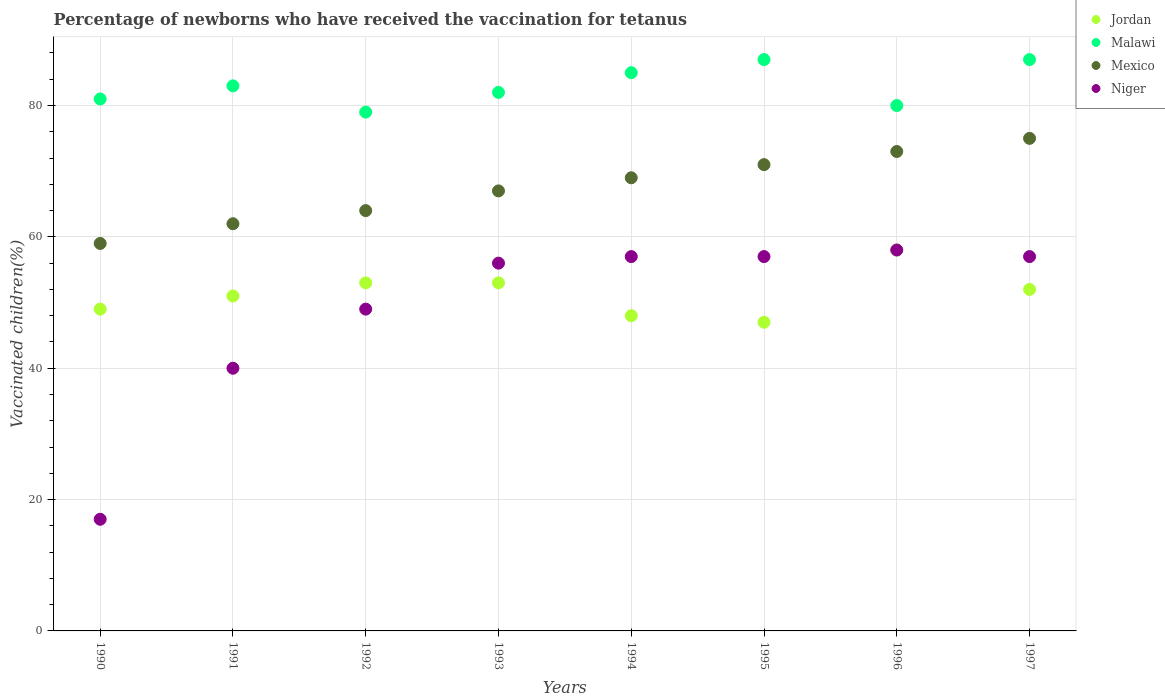Is the number of dotlines equal to the number of legend labels?
Make the answer very short. Yes. What is the percentage of vaccinated children in Jordan in 1995?
Your answer should be very brief. 47. In which year was the percentage of vaccinated children in Malawi maximum?
Offer a very short reply. 1995. What is the total percentage of vaccinated children in Jordan in the graph?
Your answer should be very brief. 411. What is the difference between the percentage of vaccinated children in Mexico in 1990 and that in 1997?
Ensure brevity in your answer.  -16. What is the difference between the percentage of vaccinated children in Mexico in 1993 and the percentage of vaccinated children in Malawi in 1991?
Give a very brief answer. -16. What is the average percentage of vaccinated children in Jordan per year?
Provide a short and direct response. 51.38. What is the ratio of the percentage of vaccinated children in Jordan in 1990 to that in 1992?
Your answer should be compact. 0.92. Is the difference between the percentage of vaccinated children in Jordan in 1990 and 1991 greater than the difference between the percentage of vaccinated children in Mexico in 1990 and 1991?
Keep it short and to the point. Yes. What is the difference between the highest and the second highest percentage of vaccinated children in Malawi?
Keep it short and to the point. 0. What is the difference between the highest and the lowest percentage of vaccinated children in Mexico?
Make the answer very short. 16. Is it the case that in every year, the sum of the percentage of vaccinated children in Niger and percentage of vaccinated children in Mexico  is greater than the sum of percentage of vaccinated children in Jordan and percentage of vaccinated children in Malawi?
Your answer should be compact. No. Does the percentage of vaccinated children in Mexico monotonically increase over the years?
Your response must be concise. Yes. Is the percentage of vaccinated children in Jordan strictly less than the percentage of vaccinated children in Mexico over the years?
Your answer should be compact. Yes. How many dotlines are there?
Offer a very short reply. 4. What is the difference between two consecutive major ticks on the Y-axis?
Your response must be concise. 20. Does the graph contain any zero values?
Give a very brief answer. No. Does the graph contain grids?
Your answer should be compact. Yes. How many legend labels are there?
Ensure brevity in your answer.  4. How are the legend labels stacked?
Ensure brevity in your answer.  Vertical. What is the title of the graph?
Keep it short and to the point. Percentage of newborns who have received the vaccination for tetanus. What is the label or title of the X-axis?
Provide a short and direct response. Years. What is the label or title of the Y-axis?
Make the answer very short. Vaccinated children(%). What is the Vaccinated children(%) in Jordan in 1990?
Offer a very short reply. 49. What is the Vaccinated children(%) of Mexico in 1990?
Make the answer very short. 59. What is the Vaccinated children(%) of Niger in 1990?
Your answer should be very brief. 17. What is the Vaccinated children(%) of Malawi in 1991?
Make the answer very short. 83. What is the Vaccinated children(%) in Niger in 1991?
Provide a succinct answer. 40. What is the Vaccinated children(%) of Malawi in 1992?
Keep it short and to the point. 79. What is the Vaccinated children(%) in Jordan in 1993?
Ensure brevity in your answer.  53. What is the Vaccinated children(%) of Malawi in 1993?
Offer a terse response. 82. What is the Vaccinated children(%) of Mexico in 1993?
Keep it short and to the point. 67. What is the Vaccinated children(%) in Niger in 1993?
Your response must be concise. 56. What is the Vaccinated children(%) in Jordan in 1994?
Offer a very short reply. 48. What is the Vaccinated children(%) in Malawi in 1994?
Provide a succinct answer. 85. What is the Vaccinated children(%) in Mexico in 1995?
Make the answer very short. 71. What is the Vaccinated children(%) in Malawi in 1996?
Your answer should be very brief. 80. What is the Vaccinated children(%) in Niger in 1996?
Provide a short and direct response. 58. What is the Vaccinated children(%) in Jordan in 1997?
Give a very brief answer. 52. What is the Vaccinated children(%) of Malawi in 1997?
Your answer should be compact. 87. What is the Vaccinated children(%) of Mexico in 1997?
Keep it short and to the point. 75. What is the Vaccinated children(%) of Niger in 1997?
Offer a very short reply. 57. Across all years, what is the maximum Vaccinated children(%) of Malawi?
Provide a succinct answer. 87. Across all years, what is the maximum Vaccinated children(%) of Mexico?
Make the answer very short. 75. Across all years, what is the minimum Vaccinated children(%) in Malawi?
Your answer should be very brief. 79. Across all years, what is the minimum Vaccinated children(%) in Niger?
Make the answer very short. 17. What is the total Vaccinated children(%) in Jordan in the graph?
Make the answer very short. 411. What is the total Vaccinated children(%) in Malawi in the graph?
Make the answer very short. 664. What is the total Vaccinated children(%) in Mexico in the graph?
Give a very brief answer. 540. What is the total Vaccinated children(%) in Niger in the graph?
Make the answer very short. 391. What is the difference between the Vaccinated children(%) in Jordan in 1990 and that in 1991?
Offer a terse response. -2. What is the difference between the Vaccinated children(%) of Mexico in 1990 and that in 1991?
Your answer should be very brief. -3. What is the difference between the Vaccinated children(%) of Niger in 1990 and that in 1991?
Offer a very short reply. -23. What is the difference between the Vaccinated children(%) in Niger in 1990 and that in 1992?
Your response must be concise. -32. What is the difference between the Vaccinated children(%) in Jordan in 1990 and that in 1993?
Make the answer very short. -4. What is the difference between the Vaccinated children(%) of Malawi in 1990 and that in 1993?
Your response must be concise. -1. What is the difference between the Vaccinated children(%) of Mexico in 1990 and that in 1993?
Offer a terse response. -8. What is the difference between the Vaccinated children(%) in Niger in 1990 and that in 1993?
Ensure brevity in your answer.  -39. What is the difference between the Vaccinated children(%) of Niger in 1990 and that in 1994?
Make the answer very short. -40. What is the difference between the Vaccinated children(%) in Jordan in 1990 and that in 1995?
Your answer should be very brief. 2. What is the difference between the Vaccinated children(%) in Malawi in 1990 and that in 1995?
Provide a short and direct response. -6. What is the difference between the Vaccinated children(%) of Malawi in 1990 and that in 1996?
Your response must be concise. 1. What is the difference between the Vaccinated children(%) of Niger in 1990 and that in 1996?
Offer a terse response. -41. What is the difference between the Vaccinated children(%) of Jordan in 1990 and that in 1997?
Your answer should be very brief. -3. What is the difference between the Vaccinated children(%) of Malawi in 1990 and that in 1997?
Provide a succinct answer. -6. What is the difference between the Vaccinated children(%) of Niger in 1990 and that in 1997?
Ensure brevity in your answer.  -40. What is the difference between the Vaccinated children(%) in Jordan in 1991 and that in 1992?
Your response must be concise. -2. What is the difference between the Vaccinated children(%) in Mexico in 1991 and that in 1992?
Your answer should be compact. -2. What is the difference between the Vaccinated children(%) in Mexico in 1991 and that in 1993?
Make the answer very short. -5. What is the difference between the Vaccinated children(%) of Niger in 1991 and that in 1993?
Offer a very short reply. -16. What is the difference between the Vaccinated children(%) of Malawi in 1991 and that in 1994?
Give a very brief answer. -2. What is the difference between the Vaccinated children(%) of Niger in 1991 and that in 1994?
Ensure brevity in your answer.  -17. What is the difference between the Vaccinated children(%) in Jordan in 1991 and that in 1995?
Provide a succinct answer. 4. What is the difference between the Vaccinated children(%) of Mexico in 1991 and that in 1995?
Make the answer very short. -9. What is the difference between the Vaccinated children(%) in Niger in 1991 and that in 1995?
Your response must be concise. -17. What is the difference between the Vaccinated children(%) of Jordan in 1991 and that in 1996?
Your answer should be compact. -7. What is the difference between the Vaccinated children(%) of Malawi in 1991 and that in 1996?
Provide a succinct answer. 3. What is the difference between the Vaccinated children(%) in Jordan in 1991 and that in 1997?
Your response must be concise. -1. What is the difference between the Vaccinated children(%) of Malawi in 1991 and that in 1997?
Make the answer very short. -4. What is the difference between the Vaccinated children(%) in Mexico in 1991 and that in 1997?
Provide a succinct answer. -13. What is the difference between the Vaccinated children(%) in Malawi in 1992 and that in 1993?
Your answer should be very brief. -3. What is the difference between the Vaccinated children(%) in Jordan in 1992 and that in 1994?
Offer a very short reply. 5. What is the difference between the Vaccinated children(%) in Niger in 1992 and that in 1994?
Your answer should be very brief. -8. What is the difference between the Vaccinated children(%) in Malawi in 1992 and that in 1995?
Make the answer very short. -8. What is the difference between the Vaccinated children(%) of Mexico in 1992 and that in 1995?
Offer a very short reply. -7. What is the difference between the Vaccinated children(%) of Jordan in 1992 and that in 1996?
Give a very brief answer. -5. What is the difference between the Vaccinated children(%) in Malawi in 1992 and that in 1996?
Provide a succinct answer. -1. What is the difference between the Vaccinated children(%) in Mexico in 1992 and that in 1996?
Provide a short and direct response. -9. What is the difference between the Vaccinated children(%) of Malawi in 1992 and that in 1997?
Keep it short and to the point. -8. What is the difference between the Vaccinated children(%) in Mexico in 1992 and that in 1997?
Give a very brief answer. -11. What is the difference between the Vaccinated children(%) of Jordan in 1993 and that in 1994?
Ensure brevity in your answer.  5. What is the difference between the Vaccinated children(%) of Mexico in 1993 and that in 1994?
Provide a short and direct response. -2. What is the difference between the Vaccinated children(%) of Niger in 1993 and that in 1994?
Give a very brief answer. -1. What is the difference between the Vaccinated children(%) in Jordan in 1993 and that in 1996?
Give a very brief answer. -5. What is the difference between the Vaccinated children(%) of Malawi in 1993 and that in 1996?
Ensure brevity in your answer.  2. What is the difference between the Vaccinated children(%) in Mexico in 1993 and that in 1996?
Your answer should be very brief. -6. What is the difference between the Vaccinated children(%) of Mexico in 1993 and that in 1997?
Make the answer very short. -8. What is the difference between the Vaccinated children(%) in Niger in 1993 and that in 1997?
Provide a succinct answer. -1. What is the difference between the Vaccinated children(%) of Malawi in 1994 and that in 1996?
Your answer should be very brief. 5. What is the difference between the Vaccinated children(%) in Mexico in 1994 and that in 1996?
Your response must be concise. -4. What is the difference between the Vaccinated children(%) of Malawi in 1994 and that in 1997?
Your response must be concise. -2. What is the difference between the Vaccinated children(%) in Mexico in 1994 and that in 1997?
Ensure brevity in your answer.  -6. What is the difference between the Vaccinated children(%) of Malawi in 1995 and that in 1996?
Keep it short and to the point. 7. What is the difference between the Vaccinated children(%) in Niger in 1995 and that in 1996?
Give a very brief answer. -1. What is the difference between the Vaccinated children(%) of Niger in 1995 and that in 1997?
Provide a succinct answer. 0. What is the difference between the Vaccinated children(%) of Jordan in 1996 and that in 1997?
Offer a terse response. 6. What is the difference between the Vaccinated children(%) of Malawi in 1996 and that in 1997?
Give a very brief answer. -7. What is the difference between the Vaccinated children(%) in Niger in 1996 and that in 1997?
Provide a short and direct response. 1. What is the difference between the Vaccinated children(%) of Jordan in 1990 and the Vaccinated children(%) of Malawi in 1991?
Your response must be concise. -34. What is the difference between the Vaccinated children(%) of Jordan in 1990 and the Vaccinated children(%) of Niger in 1991?
Your answer should be compact. 9. What is the difference between the Vaccinated children(%) in Malawi in 1990 and the Vaccinated children(%) in Mexico in 1991?
Your answer should be very brief. 19. What is the difference between the Vaccinated children(%) of Malawi in 1990 and the Vaccinated children(%) of Niger in 1991?
Give a very brief answer. 41. What is the difference between the Vaccinated children(%) of Malawi in 1990 and the Vaccinated children(%) of Niger in 1992?
Your response must be concise. 32. What is the difference between the Vaccinated children(%) of Jordan in 1990 and the Vaccinated children(%) of Malawi in 1993?
Keep it short and to the point. -33. What is the difference between the Vaccinated children(%) of Jordan in 1990 and the Vaccinated children(%) of Malawi in 1994?
Ensure brevity in your answer.  -36. What is the difference between the Vaccinated children(%) in Jordan in 1990 and the Vaccinated children(%) in Mexico in 1994?
Make the answer very short. -20. What is the difference between the Vaccinated children(%) in Malawi in 1990 and the Vaccinated children(%) in Mexico in 1994?
Your answer should be very brief. 12. What is the difference between the Vaccinated children(%) in Jordan in 1990 and the Vaccinated children(%) in Malawi in 1995?
Give a very brief answer. -38. What is the difference between the Vaccinated children(%) of Jordan in 1990 and the Vaccinated children(%) of Mexico in 1995?
Your answer should be very brief. -22. What is the difference between the Vaccinated children(%) in Malawi in 1990 and the Vaccinated children(%) in Mexico in 1995?
Your response must be concise. 10. What is the difference between the Vaccinated children(%) in Malawi in 1990 and the Vaccinated children(%) in Niger in 1995?
Your response must be concise. 24. What is the difference between the Vaccinated children(%) of Mexico in 1990 and the Vaccinated children(%) of Niger in 1995?
Provide a short and direct response. 2. What is the difference between the Vaccinated children(%) in Jordan in 1990 and the Vaccinated children(%) in Malawi in 1996?
Provide a succinct answer. -31. What is the difference between the Vaccinated children(%) of Jordan in 1990 and the Vaccinated children(%) of Niger in 1996?
Ensure brevity in your answer.  -9. What is the difference between the Vaccinated children(%) in Malawi in 1990 and the Vaccinated children(%) in Mexico in 1996?
Ensure brevity in your answer.  8. What is the difference between the Vaccinated children(%) of Malawi in 1990 and the Vaccinated children(%) of Niger in 1996?
Provide a succinct answer. 23. What is the difference between the Vaccinated children(%) of Mexico in 1990 and the Vaccinated children(%) of Niger in 1996?
Your response must be concise. 1. What is the difference between the Vaccinated children(%) of Jordan in 1990 and the Vaccinated children(%) of Malawi in 1997?
Make the answer very short. -38. What is the difference between the Vaccinated children(%) in Jordan in 1990 and the Vaccinated children(%) in Mexico in 1997?
Make the answer very short. -26. What is the difference between the Vaccinated children(%) of Jordan in 1990 and the Vaccinated children(%) of Niger in 1997?
Your response must be concise. -8. What is the difference between the Vaccinated children(%) of Malawi in 1990 and the Vaccinated children(%) of Niger in 1997?
Your answer should be very brief. 24. What is the difference between the Vaccinated children(%) in Jordan in 1991 and the Vaccinated children(%) in Malawi in 1992?
Provide a short and direct response. -28. What is the difference between the Vaccinated children(%) of Jordan in 1991 and the Vaccinated children(%) of Mexico in 1992?
Give a very brief answer. -13. What is the difference between the Vaccinated children(%) in Malawi in 1991 and the Vaccinated children(%) in Mexico in 1992?
Your response must be concise. 19. What is the difference between the Vaccinated children(%) of Jordan in 1991 and the Vaccinated children(%) of Malawi in 1993?
Provide a succinct answer. -31. What is the difference between the Vaccinated children(%) of Jordan in 1991 and the Vaccinated children(%) of Mexico in 1993?
Provide a short and direct response. -16. What is the difference between the Vaccinated children(%) of Malawi in 1991 and the Vaccinated children(%) of Mexico in 1993?
Make the answer very short. 16. What is the difference between the Vaccinated children(%) of Mexico in 1991 and the Vaccinated children(%) of Niger in 1993?
Offer a terse response. 6. What is the difference between the Vaccinated children(%) of Jordan in 1991 and the Vaccinated children(%) of Malawi in 1994?
Offer a terse response. -34. What is the difference between the Vaccinated children(%) of Jordan in 1991 and the Vaccinated children(%) of Niger in 1994?
Offer a very short reply. -6. What is the difference between the Vaccinated children(%) in Malawi in 1991 and the Vaccinated children(%) in Mexico in 1994?
Offer a very short reply. 14. What is the difference between the Vaccinated children(%) of Malawi in 1991 and the Vaccinated children(%) of Niger in 1994?
Provide a short and direct response. 26. What is the difference between the Vaccinated children(%) in Mexico in 1991 and the Vaccinated children(%) in Niger in 1994?
Make the answer very short. 5. What is the difference between the Vaccinated children(%) in Jordan in 1991 and the Vaccinated children(%) in Malawi in 1995?
Your response must be concise. -36. What is the difference between the Vaccinated children(%) in Jordan in 1991 and the Vaccinated children(%) in Mexico in 1995?
Ensure brevity in your answer.  -20. What is the difference between the Vaccinated children(%) of Malawi in 1991 and the Vaccinated children(%) of Mexico in 1995?
Your answer should be very brief. 12. What is the difference between the Vaccinated children(%) in Malawi in 1991 and the Vaccinated children(%) in Niger in 1995?
Give a very brief answer. 26. What is the difference between the Vaccinated children(%) of Mexico in 1991 and the Vaccinated children(%) of Niger in 1995?
Offer a terse response. 5. What is the difference between the Vaccinated children(%) of Jordan in 1991 and the Vaccinated children(%) of Malawi in 1996?
Give a very brief answer. -29. What is the difference between the Vaccinated children(%) of Jordan in 1991 and the Vaccinated children(%) of Mexico in 1996?
Your answer should be very brief. -22. What is the difference between the Vaccinated children(%) in Malawi in 1991 and the Vaccinated children(%) in Mexico in 1996?
Provide a succinct answer. 10. What is the difference between the Vaccinated children(%) in Malawi in 1991 and the Vaccinated children(%) in Niger in 1996?
Offer a very short reply. 25. What is the difference between the Vaccinated children(%) of Jordan in 1991 and the Vaccinated children(%) of Malawi in 1997?
Provide a succinct answer. -36. What is the difference between the Vaccinated children(%) of Jordan in 1991 and the Vaccinated children(%) of Mexico in 1997?
Keep it short and to the point. -24. What is the difference between the Vaccinated children(%) of Malawi in 1991 and the Vaccinated children(%) of Niger in 1997?
Your answer should be compact. 26. What is the difference between the Vaccinated children(%) of Jordan in 1992 and the Vaccinated children(%) of Malawi in 1993?
Your response must be concise. -29. What is the difference between the Vaccinated children(%) of Jordan in 1992 and the Vaccinated children(%) of Niger in 1993?
Keep it short and to the point. -3. What is the difference between the Vaccinated children(%) in Malawi in 1992 and the Vaccinated children(%) in Niger in 1993?
Your answer should be compact. 23. What is the difference between the Vaccinated children(%) in Jordan in 1992 and the Vaccinated children(%) in Malawi in 1994?
Your response must be concise. -32. What is the difference between the Vaccinated children(%) of Malawi in 1992 and the Vaccinated children(%) of Mexico in 1994?
Provide a succinct answer. 10. What is the difference between the Vaccinated children(%) of Jordan in 1992 and the Vaccinated children(%) of Malawi in 1995?
Provide a succinct answer. -34. What is the difference between the Vaccinated children(%) of Jordan in 1992 and the Vaccinated children(%) of Mexico in 1995?
Provide a succinct answer. -18. What is the difference between the Vaccinated children(%) in Malawi in 1992 and the Vaccinated children(%) in Mexico in 1995?
Make the answer very short. 8. What is the difference between the Vaccinated children(%) in Malawi in 1992 and the Vaccinated children(%) in Niger in 1995?
Your answer should be compact. 22. What is the difference between the Vaccinated children(%) of Jordan in 1992 and the Vaccinated children(%) of Mexico in 1996?
Make the answer very short. -20. What is the difference between the Vaccinated children(%) of Jordan in 1992 and the Vaccinated children(%) of Niger in 1996?
Your answer should be compact. -5. What is the difference between the Vaccinated children(%) in Malawi in 1992 and the Vaccinated children(%) in Niger in 1996?
Your answer should be very brief. 21. What is the difference between the Vaccinated children(%) in Mexico in 1992 and the Vaccinated children(%) in Niger in 1996?
Provide a short and direct response. 6. What is the difference between the Vaccinated children(%) in Jordan in 1992 and the Vaccinated children(%) in Malawi in 1997?
Your answer should be very brief. -34. What is the difference between the Vaccinated children(%) in Jordan in 1992 and the Vaccinated children(%) in Mexico in 1997?
Provide a short and direct response. -22. What is the difference between the Vaccinated children(%) in Malawi in 1992 and the Vaccinated children(%) in Mexico in 1997?
Your response must be concise. 4. What is the difference between the Vaccinated children(%) in Malawi in 1992 and the Vaccinated children(%) in Niger in 1997?
Provide a succinct answer. 22. What is the difference between the Vaccinated children(%) in Mexico in 1992 and the Vaccinated children(%) in Niger in 1997?
Ensure brevity in your answer.  7. What is the difference between the Vaccinated children(%) of Jordan in 1993 and the Vaccinated children(%) of Malawi in 1994?
Your response must be concise. -32. What is the difference between the Vaccinated children(%) in Jordan in 1993 and the Vaccinated children(%) in Mexico in 1994?
Your answer should be very brief. -16. What is the difference between the Vaccinated children(%) in Jordan in 1993 and the Vaccinated children(%) in Niger in 1994?
Your answer should be very brief. -4. What is the difference between the Vaccinated children(%) of Malawi in 1993 and the Vaccinated children(%) of Mexico in 1994?
Provide a short and direct response. 13. What is the difference between the Vaccinated children(%) in Malawi in 1993 and the Vaccinated children(%) in Niger in 1994?
Ensure brevity in your answer.  25. What is the difference between the Vaccinated children(%) in Mexico in 1993 and the Vaccinated children(%) in Niger in 1994?
Provide a short and direct response. 10. What is the difference between the Vaccinated children(%) of Jordan in 1993 and the Vaccinated children(%) of Malawi in 1995?
Ensure brevity in your answer.  -34. What is the difference between the Vaccinated children(%) of Jordan in 1993 and the Vaccinated children(%) of Mexico in 1995?
Provide a succinct answer. -18. What is the difference between the Vaccinated children(%) of Malawi in 1993 and the Vaccinated children(%) of Niger in 1995?
Offer a terse response. 25. What is the difference between the Vaccinated children(%) of Mexico in 1993 and the Vaccinated children(%) of Niger in 1995?
Keep it short and to the point. 10. What is the difference between the Vaccinated children(%) of Jordan in 1993 and the Vaccinated children(%) of Malawi in 1996?
Ensure brevity in your answer.  -27. What is the difference between the Vaccinated children(%) in Jordan in 1993 and the Vaccinated children(%) in Mexico in 1996?
Your answer should be very brief. -20. What is the difference between the Vaccinated children(%) in Malawi in 1993 and the Vaccinated children(%) in Mexico in 1996?
Your answer should be very brief. 9. What is the difference between the Vaccinated children(%) in Malawi in 1993 and the Vaccinated children(%) in Niger in 1996?
Your answer should be very brief. 24. What is the difference between the Vaccinated children(%) in Jordan in 1993 and the Vaccinated children(%) in Malawi in 1997?
Offer a very short reply. -34. What is the difference between the Vaccinated children(%) in Mexico in 1993 and the Vaccinated children(%) in Niger in 1997?
Give a very brief answer. 10. What is the difference between the Vaccinated children(%) of Jordan in 1994 and the Vaccinated children(%) of Malawi in 1995?
Make the answer very short. -39. What is the difference between the Vaccinated children(%) of Jordan in 1994 and the Vaccinated children(%) of Mexico in 1995?
Provide a succinct answer. -23. What is the difference between the Vaccinated children(%) in Jordan in 1994 and the Vaccinated children(%) in Niger in 1995?
Provide a short and direct response. -9. What is the difference between the Vaccinated children(%) of Mexico in 1994 and the Vaccinated children(%) of Niger in 1995?
Give a very brief answer. 12. What is the difference between the Vaccinated children(%) of Jordan in 1994 and the Vaccinated children(%) of Malawi in 1996?
Provide a succinct answer. -32. What is the difference between the Vaccinated children(%) of Jordan in 1994 and the Vaccinated children(%) of Mexico in 1996?
Your answer should be very brief. -25. What is the difference between the Vaccinated children(%) in Mexico in 1994 and the Vaccinated children(%) in Niger in 1996?
Your response must be concise. 11. What is the difference between the Vaccinated children(%) in Jordan in 1994 and the Vaccinated children(%) in Malawi in 1997?
Give a very brief answer. -39. What is the difference between the Vaccinated children(%) of Malawi in 1994 and the Vaccinated children(%) of Mexico in 1997?
Your answer should be compact. 10. What is the difference between the Vaccinated children(%) in Mexico in 1994 and the Vaccinated children(%) in Niger in 1997?
Ensure brevity in your answer.  12. What is the difference between the Vaccinated children(%) in Jordan in 1995 and the Vaccinated children(%) in Malawi in 1996?
Make the answer very short. -33. What is the difference between the Vaccinated children(%) of Jordan in 1995 and the Vaccinated children(%) of Mexico in 1996?
Offer a very short reply. -26. What is the difference between the Vaccinated children(%) of Jordan in 1995 and the Vaccinated children(%) of Niger in 1996?
Your answer should be compact. -11. What is the difference between the Vaccinated children(%) of Jordan in 1995 and the Vaccinated children(%) of Mexico in 1997?
Your response must be concise. -28. What is the difference between the Vaccinated children(%) in Jordan in 1995 and the Vaccinated children(%) in Niger in 1997?
Offer a terse response. -10. What is the difference between the Vaccinated children(%) in Malawi in 1995 and the Vaccinated children(%) in Niger in 1997?
Offer a very short reply. 30. What is the difference between the Vaccinated children(%) in Jordan in 1996 and the Vaccinated children(%) in Mexico in 1997?
Your answer should be very brief. -17. What is the difference between the Vaccinated children(%) in Jordan in 1996 and the Vaccinated children(%) in Niger in 1997?
Provide a succinct answer. 1. What is the difference between the Vaccinated children(%) in Malawi in 1996 and the Vaccinated children(%) in Mexico in 1997?
Keep it short and to the point. 5. What is the average Vaccinated children(%) in Jordan per year?
Provide a succinct answer. 51.38. What is the average Vaccinated children(%) of Malawi per year?
Make the answer very short. 83. What is the average Vaccinated children(%) of Mexico per year?
Your answer should be very brief. 67.5. What is the average Vaccinated children(%) in Niger per year?
Keep it short and to the point. 48.88. In the year 1990, what is the difference between the Vaccinated children(%) in Jordan and Vaccinated children(%) in Malawi?
Offer a very short reply. -32. In the year 1990, what is the difference between the Vaccinated children(%) in Jordan and Vaccinated children(%) in Mexico?
Keep it short and to the point. -10. In the year 1990, what is the difference between the Vaccinated children(%) in Malawi and Vaccinated children(%) in Mexico?
Your response must be concise. 22. In the year 1990, what is the difference between the Vaccinated children(%) in Mexico and Vaccinated children(%) in Niger?
Provide a succinct answer. 42. In the year 1991, what is the difference between the Vaccinated children(%) of Jordan and Vaccinated children(%) of Malawi?
Your answer should be very brief. -32. In the year 1991, what is the difference between the Vaccinated children(%) of Malawi and Vaccinated children(%) of Niger?
Ensure brevity in your answer.  43. In the year 1991, what is the difference between the Vaccinated children(%) of Mexico and Vaccinated children(%) of Niger?
Provide a short and direct response. 22. In the year 1992, what is the difference between the Vaccinated children(%) of Jordan and Vaccinated children(%) of Mexico?
Your answer should be compact. -11. In the year 1992, what is the difference between the Vaccinated children(%) of Jordan and Vaccinated children(%) of Niger?
Your response must be concise. 4. In the year 1992, what is the difference between the Vaccinated children(%) in Malawi and Vaccinated children(%) in Mexico?
Your response must be concise. 15. In the year 1992, what is the difference between the Vaccinated children(%) in Malawi and Vaccinated children(%) in Niger?
Ensure brevity in your answer.  30. In the year 1992, what is the difference between the Vaccinated children(%) in Mexico and Vaccinated children(%) in Niger?
Your answer should be compact. 15. In the year 1993, what is the difference between the Vaccinated children(%) in Jordan and Vaccinated children(%) in Malawi?
Ensure brevity in your answer.  -29. In the year 1993, what is the difference between the Vaccinated children(%) in Jordan and Vaccinated children(%) in Mexico?
Your answer should be very brief. -14. In the year 1993, what is the difference between the Vaccinated children(%) of Jordan and Vaccinated children(%) of Niger?
Provide a succinct answer. -3. In the year 1993, what is the difference between the Vaccinated children(%) of Malawi and Vaccinated children(%) of Mexico?
Provide a succinct answer. 15. In the year 1993, what is the difference between the Vaccinated children(%) of Malawi and Vaccinated children(%) of Niger?
Your response must be concise. 26. In the year 1994, what is the difference between the Vaccinated children(%) of Jordan and Vaccinated children(%) of Malawi?
Keep it short and to the point. -37. In the year 1994, what is the difference between the Vaccinated children(%) in Jordan and Vaccinated children(%) in Niger?
Give a very brief answer. -9. In the year 1994, what is the difference between the Vaccinated children(%) of Malawi and Vaccinated children(%) of Mexico?
Offer a terse response. 16. In the year 1994, what is the difference between the Vaccinated children(%) of Malawi and Vaccinated children(%) of Niger?
Keep it short and to the point. 28. In the year 1994, what is the difference between the Vaccinated children(%) of Mexico and Vaccinated children(%) of Niger?
Keep it short and to the point. 12. In the year 1995, what is the difference between the Vaccinated children(%) of Jordan and Vaccinated children(%) of Niger?
Your answer should be compact. -10. In the year 1995, what is the difference between the Vaccinated children(%) of Malawi and Vaccinated children(%) of Mexico?
Make the answer very short. 16. In the year 1995, what is the difference between the Vaccinated children(%) in Malawi and Vaccinated children(%) in Niger?
Your response must be concise. 30. In the year 1995, what is the difference between the Vaccinated children(%) in Mexico and Vaccinated children(%) in Niger?
Keep it short and to the point. 14. In the year 1996, what is the difference between the Vaccinated children(%) in Jordan and Vaccinated children(%) in Malawi?
Provide a short and direct response. -22. In the year 1996, what is the difference between the Vaccinated children(%) of Jordan and Vaccinated children(%) of Mexico?
Give a very brief answer. -15. In the year 1996, what is the difference between the Vaccinated children(%) in Jordan and Vaccinated children(%) in Niger?
Provide a succinct answer. 0. In the year 1996, what is the difference between the Vaccinated children(%) of Malawi and Vaccinated children(%) of Niger?
Keep it short and to the point. 22. In the year 1997, what is the difference between the Vaccinated children(%) in Jordan and Vaccinated children(%) in Malawi?
Give a very brief answer. -35. In the year 1997, what is the difference between the Vaccinated children(%) of Jordan and Vaccinated children(%) of Mexico?
Your response must be concise. -23. In the year 1997, what is the difference between the Vaccinated children(%) in Malawi and Vaccinated children(%) in Niger?
Keep it short and to the point. 30. What is the ratio of the Vaccinated children(%) of Jordan in 1990 to that in 1991?
Your answer should be very brief. 0.96. What is the ratio of the Vaccinated children(%) in Malawi in 1990 to that in 1991?
Give a very brief answer. 0.98. What is the ratio of the Vaccinated children(%) of Mexico in 1990 to that in 1991?
Your response must be concise. 0.95. What is the ratio of the Vaccinated children(%) of Niger in 1990 to that in 1991?
Your answer should be compact. 0.42. What is the ratio of the Vaccinated children(%) of Jordan in 1990 to that in 1992?
Offer a terse response. 0.92. What is the ratio of the Vaccinated children(%) in Malawi in 1990 to that in 1992?
Give a very brief answer. 1.03. What is the ratio of the Vaccinated children(%) of Mexico in 1990 to that in 1992?
Offer a terse response. 0.92. What is the ratio of the Vaccinated children(%) of Niger in 1990 to that in 1992?
Give a very brief answer. 0.35. What is the ratio of the Vaccinated children(%) of Jordan in 1990 to that in 1993?
Your response must be concise. 0.92. What is the ratio of the Vaccinated children(%) of Mexico in 1990 to that in 1993?
Ensure brevity in your answer.  0.88. What is the ratio of the Vaccinated children(%) of Niger in 1990 to that in 1993?
Give a very brief answer. 0.3. What is the ratio of the Vaccinated children(%) in Jordan in 1990 to that in 1994?
Make the answer very short. 1.02. What is the ratio of the Vaccinated children(%) of Malawi in 1990 to that in 1994?
Keep it short and to the point. 0.95. What is the ratio of the Vaccinated children(%) in Mexico in 1990 to that in 1994?
Offer a very short reply. 0.86. What is the ratio of the Vaccinated children(%) of Niger in 1990 to that in 1994?
Your answer should be very brief. 0.3. What is the ratio of the Vaccinated children(%) of Jordan in 1990 to that in 1995?
Your answer should be compact. 1.04. What is the ratio of the Vaccinated children(%) of Mexico in 1990 to that in 1995?
Provide a short and direct response. 0.83. What is the ratio of the Vaccinated children(%) in Niger in 1990 to that in 1995?
Your answer should be compact. 0.3. What is the ratio of the Vaccinated children(%) of Jordan in 1990 to that in 1996?
Provide a succinct answer. 0.84. What is the ratio of the Vaccinated children(%) of Malawi in 1990 to that in 1996?
Offer a very short reply. 1.01. What is the ratio of the Vaccinated children(%) of Mexico in 1990 to that in 1996?
Offer a very short reply. 0.81. What is the ratio of the Vaccinated children(%) of Niger in 1990 to that in 1996?
Offer a terse response. 0.29. What is the ratio of the Vaccinated children(%) of Jordan in 1990 to that in 1997?
Offer a terse response. 0.94. What is the ratio of the Vaccinated children(%) in Mexico in 1990 to that in 1997?
Offer a very short reply. 0.79. What is the ratio of the Vaccinated children(%) of Niger in 1990 to that in 1997?
Your answer should be very brief. 0.3. What is the ratio of the Vaccinated children(%) in Jordan in 1991 to that in 1992?
Offer a terse response. 0.96. What is the ratio of the Vaccinated children(%) in Malawi in 1991 to that in 1992?
Provide a short and direct response. 1.05. What is the ratio of the Vaccinated children(%) in Mexico in 1991 to that in 1992?
Your answer should be very brief. 0.97. What is the ratio of the Vaccinated children(%) of Niger in 1991 to that in 1992?
Provide a short and direct response. 0.82. What is the ratio of the Vaccinated children(%) of Jordan in 1991 to that in 1993?
Provide a succinct answer. 0.96. What is the ratio of the Vaccinated children(%) in Malawi in 1991 to that in 1993?
Offer a very short reply. 1.01. What is the ratio of the Vaccinated children(%) in Mexico in 1991 to that in 1993?
Provide a succinct answer. 0.93. What is the ratio of the Vaccinated children(%) in Jordan in 1991 to that in 1994?
Keep it short and to the point. 1.06. What is the ratio of the Vaccinated children(%) of Malawi in 1991 to that in 1994?
Provide a short and direct response. 0.98. What is the ratio of the Vaccinated children(%) in Mexico in 1991 to that in 1994?
Keep it short and to the point. 0.9. What is the ratio of the Vaccinated children(%) in Niger in 1991 to that in 1994?
Your answer should be very brief. 0.7. What is the ratio of the Vaccinated children(%) of Jordan in 1991 to that in 1995?
Provide a short and direct response. 1.09. What is the ratio of the Vaccinated children(%) of Malawi in 1991 to that in 1995?
Provide a short and direct response. 0.95. What is the ratio of the Vaccinated children(%) of Mexico in 1991 to that in 1995?
Make the answer very short. 0.87. What is the ratio of the Vaccinated children(%) of Niger in 1991 to that in 1995?
Offer a terse response. 0.7. What is the ratio of the Vaccinated children(%) of Jordan in 1991 to that in 1996?
Keep it short and to the point. 0.88. What is the ratio of the Vaccinated children(%) in Malawi in 1991 to that in 1996?
Make the answer very short. 1.04. What is the ratio of the Vaccinated children(%) of Mexico in 1991 to that in 1996?
Offer a terse response. 0.85. What is the ratio of the Vaccinated children(%) in Niger in 1991 to that in 1996?
Ensure brevity in your answer.  0.69. What is the ratio of the Vaccinated children(%) in Jordan in 1991 to that in 1997?
Offer a terse response. 0.98. What is the ratio of the Vaccinated children(%) of Malawi in 1991 to that in 1997?
Offer a terse response. 0.95. What is the ratio of the Vaccinated children(%) in Mexico in 1991 to that in 1997?
Keep it short and to the point. 0.83. What is the ratio of the Vaccinated children(%) of Niger in 1991 to that in 1997?
Your response must be concise. 0.7. What is the ratio of the Vaccinated children(%) of Jordan in 1992 to that in 1993?
Ensure brevity in your answer.  1. What is the ratio of the Vaccinated children(%) of Malawi in 1992 to that in 1993?
Provide a succinct answer. 0.96. What is the ratio of the Vaccinated children(%) of Mexico in 1992 to that in 1993?
Make the answer very short. 0.96. What is the ratio of the Vaccinated children(%) in Jordan in 1992 to that in 1994?
Your response must be concise. 1.1. What is the ratio of the Vaccinated children(%) of Malawi in 1992 to that in 1994?
Your response must be concise. 0.93. What is the ratio of the Vaccinated children(%) of Mexico in 1992 to that in 1994?
Offer a very short reply. 0.93. What is the ratio of the Vaccinated children(%) in Niger in 1992 to that in 1994?
Provide a succinct answer. 0.86. What is the ratio of the Vaccinated children(%) of Jordan in 1992 to that in 1995?
Make the answer very short. 1.13. What is the ratio of the Vaccinated children(%) of Malawi in 1992 to that in 1995?
Make the answer very short. 0.91. What is the ratio of the Vaccinated children(%) in Mexico in 1992 to that in 1995?
Ensure brevity in your answer.  0.9. What is the ratio of the Vaccinated children(%) of Niger in 1992 to that in 1995?
Your answer should be compact. 0.86. What is the ratio of the Vaccinated children(%) of Jordan in 1992 to that in 1996?
Provide a succinct answer. 0.91. What is the ratio of the Vaccinated children(%) in Malawi in 1992 to that in 1996?
Offer a very short reply. 0.99. What is the ratio of the Vaccinated children(%) of Mexico in 1992 to that in 1996?
Provide a succinct answer. 0.88. What is the ratio of the Vaccinated children(%) in Niger in 1992 to that in 1996?
Provide a short and direct response. 0.84. What is the ratio of the Vaccinated children(%) of Jordan in 1992 to that in 1997?
Offer a terse response. 1.02. What is the ratio of the Vaccinated children(%) of Malawi in 1992 to that in 1997?
Give a very brief answer. 0.91. What is the ratio of the Vaccinated children(%) in Mexico in 1992 to that in 1997?
Your answer should be compact. 0.85. What is the ratio of the Vaccinated children(%) of Niger in 1992 to that in 1997?
Provide a succinct answer. 0.86. What is the ratio of the Vaccinated children(%) in Jordan in 1993 to that in 1994?
Make the answer very short. 1.1. What is the ratio of the Vaccinated children(%) in Malawi in 1993 to that in 1994?
Offer a very short reply. 0.96. What is the ratio of the Vaccinated children(%) in Mexico in 1993 to that in 1994?
Give a very brief answer. 0.97. What is the ratio of the Vaccinated children(%) of Niger in 1993 to that in 1994?
Provide a short and direct response. 0.98. What is the ratio of the Vaccinated children(%) of Jordan in 1993 to that in 1995?
Offer a very short reply. 1.13. What is the ratio of the Vaccinated children(%) in Malawi in 1993 to that in 1995?
Keep it short and to the point. 0.94. What is the ratio of the Vaccinated children(%) of Mexico in 1993 to that in 1995?
Make the answer very short. 0.94. What is the ratio of the Vaccinated children(%) of Niger in 1993 to that in 1995?
Your answer should be compact. 0.98. What is the ratio of the Vaccinated children(%) of Jordan in 1993 to that in 1996?
Your answer should be very brief. 0.91. What is the ratio of the Vaccinated children(%) in Mexico in 1993 to that in 1996?
Your answer should be compact. 0.92. What is the ratio of the Vaccinated children(%) in Niger in 1993 to that in 1996?
Offer a very short reply. 0.97. What is the ratio of the Vaccinated children(%) of Jordan in 1993 to that in 1997?
Ensure brevity in your answer.  1.02. What is the ratio of the Vaccinated children(%) of Malawi in 1993 to that in 1997?
Ensure brevity in your answer.  0.94. What is the ratio of the Vaccinated children(%) of Mexico in 1993 to that in 1997?
Offer a terse response. 0.89. What is the ratio of the Vaccinated children(%) in Niger in 1993 to that in 1997?
Your response must be concise. 0.98. What is the ratio of the Vaccinated children(%) in Jordan in 1994 to that in 1995?
Offer a terse response. 1.02. What is the ratio of the Vaccinated children(%) of Mexico in 1994 to that in 1995?
Ensure brevity in your answer.  0.97. What is the ratio of the Vaccinated children(%) in Jordan in 1994 to that in 1996?
Give a very brief answer. 0.83. What is the ratio of the Vaccinated children(%) in Malawi in 1994 to that in 1996?
Provide a short and direct response. 1.06. What is the ratio of the Vaccinated children(%) in Mexico in 1994 to that in 1996?
Give a very brief answer. 0.95. What is the ratio of the Vaccinated children(%) in Niger in 1994 to that in 1996?
Keep it short and to the point. 0.98. What is the ratio of the Vaccinated children(%) of Jordan in 1994 to that in 1997?
Provide a succinct answer. 0.92. What is the ratio of the Vaccinated children(%) in Malawi in 1994 to that in 1997?
Make the answer very short. 0.98. What is the ratio of the Vaccinated children(%) of Jordan in 1995 to that in 1996?
Your response must be concise. 0.81. What is the ratio of the Vaccinated children(%) of Malawi in 1995 to that in 1996?
Your response must be concise. 1.09. What is the ratio of the Vaccinated children(%) in Mexico in 1995 to that in 1996?
Your response must be concise. 0.97. What is the ratio of the Vaccinated children(%) of Niger in 1995 to that in 1996?
Your answer should be compact. 0.98. What is the ratio of the Vaccinated children(%) of Jordan in 1995 to that in 1997?
Keep it short and to the point. 0.9. What is the ratio of the Vaccinated children(%) in Mexico in 1995 to that in 1997?
Your answer should be very brief. 0.95. What is the ratio of the Vaccinated children(%) in Niger in 1995 to that in 1997?
Your answer should be very brief. 1. What is the ratio of the Vaccinated children(%) of Jordan in 1996 to that in 1997?
Offer a very short reply. 1.12. What is the ratio of the Vaccinated children(%) in Malawi in 1996 to that in 1997?
Your response must be concise. 0.92. What is the ratio of the Vaccinated children(%) in Mexico in 1996 to that in 1997?
Make the answer very short. 0.97. What is the ratio of the Vaccinated children(%) of Niger in 1996 to that in 1997?
Offer a terse response. 1.02. What is the difference between the highest and the second highest Vaccinated children(%) of Malawi?
Make the answer very short. 0. What is the difference between the highest and the second highest Vaccinated children(%) in Mexico?
Make the answer very short. 2. What is the difference between the highest and the second highest Vaccinated children(%) of Niger?
Your answer should be compact. 1. What is the difference between the highest and the lowest Vaccinated children(%) in Jordan?
Provide a short and direct response. 11. What is the difference between the highest and the lowest Vaccinated children(%) in Malawi?
Offer a terse response. 8. What is the difference between the highest and the lowest Vaccinated children(%) in Mexico?
Your answer should be compact. 16. What is the difference between the highest and the lowest Vaccinated children(%) of Niger?
Make the answer very short. 41. 